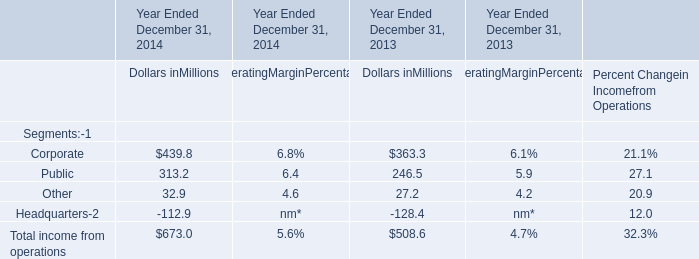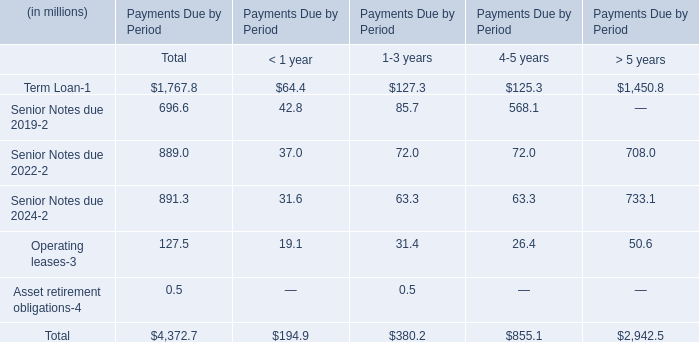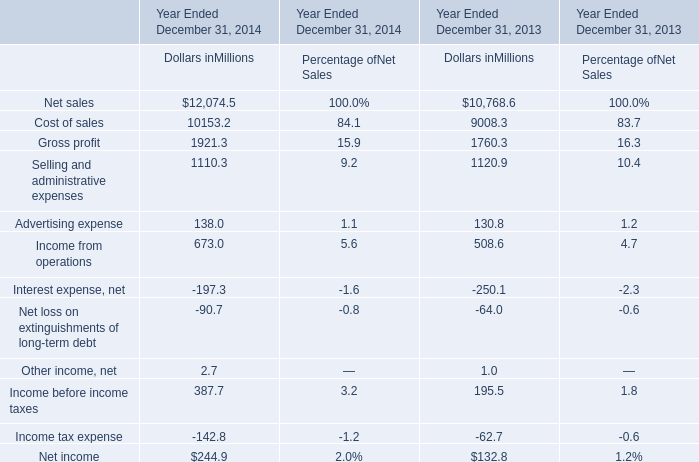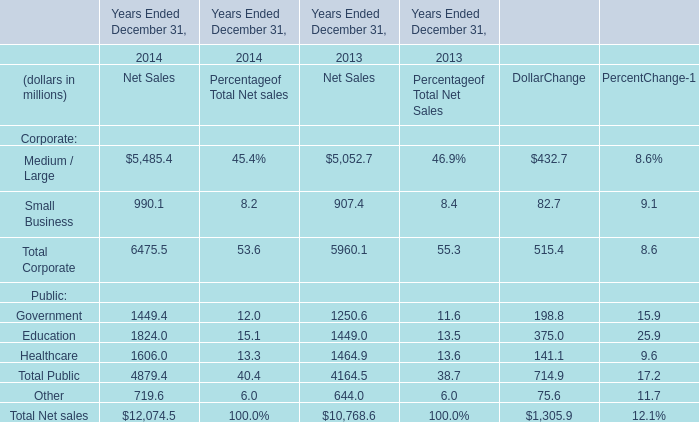What's the average of Net sales of Year Ended December 31, 2013 Dollars inMillions, and Term Loan of Payments Due by Period > 5 years ? 
Computations: ((10768.6 + 1450.8) / 2)
Answer: 6109.7. 